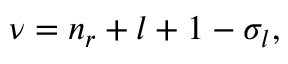<formula> <loc_0><loc_0><loc_500><loc_500>\begin{array} { r } { \nu = n _ { r } + l + 1 - \sigma _ { l } , } \end{array}</formula> 